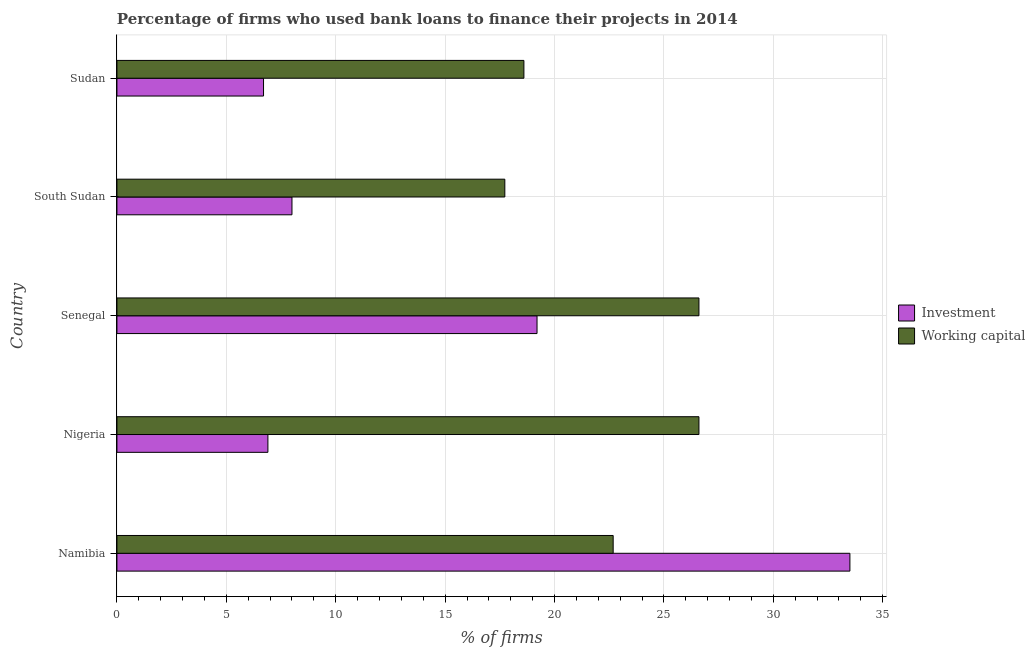Are the number of bars per tick equal to the number of legend labels?
Offer a terse response. Yes. Are the number of bars on each tick of the Y-axis equal?
Ensure brevity in your answer.  Yes. How many bars are there on the 5th tick from the top?
Ensure brevity in your answer.  2. How many bars are there on the 4th tick from the bottom?
Offer a very short reply. 2. What is the label of the 2nd group of bars from the top?
Keep it short and to the point. South Sudan. What is the percentage of firms using banks to finance investment in Sudan?
Offer a very short reply. 6.7. Across all countries, what is the maximum percentage of firms using banks to finance working capital?
Keep it short and to the point. 26.6. Across all countries, what is the minimum percentage of firms using banks to finance investment?
Ensure brevity in your answer.  6.7. In which country was the percentage of firms using banks to finance working capital maximum?
Your answer should be compact. Nigeria. In which country was the percentage of firms using banks to finance working capital minimum?
Your answer should be compact. South Sudan. What is the total percentage of firms using banks to finance working capital in the graph?
Offer a terse response. 112.21. What is the difference between the percentage of firms using banks to finance working capital in Namibia and that in Senegal?
Your answer should be compact. -3.92. What is the difference between the percentage of firms using banks to finance working capital in Sudan and the percentage of firms using banks to finance investment in Senegal?
Ensure brevity in your answer.  -0.6. What is the average percentage of firms using banks to finance investment per country?
Offer a very short reply. 14.86. What is the difference between the percentage of firms using banks to finance investment and percentage of firms using banks to finance working capital in Senegal?
Provide a succinct answer. -7.4. In how many countries, is the percentage of firms using banks to finance investment greater than 24 %?
Offer a terse response. 1. What is the ratio of the percentage of firms using banks to finance investment in Namibia to that in South Sudan?
Your answer should be compact. 4.19. What is the difference between the highest and the lowest percentage of firms using banks to finance working capital?
Give a very brief answer. 8.87. In how many countries, is the percentage of firms using banks to finance working capital greater than the average percentage of firms using banks to finance working capital taken over all countries?
Offer a very short reply. 3. Is the sum of the percentage of firms using banks to finance working capital in Senegal and South Sudan greater than the maximum percentage of firms using banks to finance investment across all countries?
Your answer should be very brief. Yes. What does the 1st bar from the top in Senegal represents?
Make the answer very short. Working capital. What does the 2nd bar from the bottom in Sudan represents?
Give a very brief answer. Working capital. Are all the bars in the graph horizontal?
Offer a terse response. Yes. How many countries are there in the graph?
Your answer should be very brief. 5. What is the difference between two consecutive major ticks on the X-axis?
Ensure brevity in your answer.  5. Are the values on the major ticks of X-axis written in scientific E-notation?
Your answer should be compact. No. Does the graph contain any zero values?
Your response must be concise. No. Does the graph contain grids?
Ensure brevity in your answer.  Yes. How many legend labels are there?
Offer a very short reply. 2. How are the legend labels stacked?
Offer a terse response. Vertical. What is the title of the graph?
Ensure brevity in your answer.  Percentage of firms who used bank loans to finance their projects in 2014. Does "Working only" appear as one of the legend labels in the graph?
Offer a terse response. No. What is the label or title of the X-axis?
Your response must be concise. % of firms. What is the label or title of the Y-axis?
Your answer should be compact. Country. What is the % of firms in Investment in Namibia?
Your response must be concise. 33.5. What is the % of firms in Working capital in Namibia?
Give a very brief answer. 22.68. What is the % of firms in Working capital in Nigeria?
Offer a terse response. 26.6. What is the % of firms of Investment in Senegal?
Your answer should be compact. 19.2. What is the % of firms of Working capital in Senegal?
Your response must be concise. 26.6. What is the % of firms in Working capital in South Sudan?
Offer a terse response. 17.73. Across all countries, what is the maximum % of firms of Investment?
Make the answer very short. 33.5. Across all countries, what is the maximum % of firms of Working capital?
Ensure brevity in your answer.  26.6. Across all countries, what is the minimum % of firms in Working capital?
Provide a succinct answer. 17.73. What is the total % of firms in Investment in the graph?
Offer a very short reply. 74.3. What is the total % of firms of Working capital in the graph?
Your answer should be compact. 112.21. What is the difference between the % of firms in Investment in Namibia and that in Nigeria?
Keep it short and to the point. 26.6. What is the difference between the % of firms of Working capital in Namibia and that in Nigeria?
Offer a very short reply. -3.92. What is the difference between the % of firms of Investment in Namibia and that in Senegal?
Give a very brief answer. 14.3. What is the difference between the % of firms in Working capital in Namibia and that in Senegal?
Your response must be concise. -3.92. What is the difference between the % of firms of Investment in Namibia and that in South Sudan?
Your answer should be very brief. 25.5. What is the difference between the % of firms of Working capital in Namibia and that in South Sudan?
Make the answer very short. 4.95. What is the difference between the % of firms in Investment in Namibia and that in Sudan?
Ensure brevity in your answer.  26.8. What is the difference between the % of firms in Working capital in Namibia and that in Sudan?
Offer a terse response. 4.08. What is the difference between the % of firms in Investment in Nigeria and that in Senegal?
Provide a succinct answer. -12.3. What is the difference between the % of firms of Working capital in Nigeria and that in South Sudan?
Your answer should be very brief. 8.87. What is the difference between the % of firms in Investment in Nigeria and that in Sudan?
Make the answer very short. 0.2. What is the difference between the % of firms in Working capital in Nigeria and that in Sudan?
Your answer should be very brief. 8. What is the difference between the % of firms in Investment in Senegal and that in South Sudan?
Your answer should be compact. 11.2. What is the difference between the % of firms of Working capital in Senegal and that in South Sudan?
Keep it short and to the point. 8.87. What is the difference between the % of firms of Investment in Senegal and that in Sudan?
Ensure brevity in your answer.  12.5. What is the difference between the % of firms of Working capital in South Sudan and that in Sudan?
Offer a terse response. -0.87. What is the difference between the % of firms in Investment in Namibia and the % of firms in Working capital in Nigeria?
Make the answer very short. 6.9. What is the difference between the % of firms in Investment in Namibia and the % of firms in Working capital in Senegal?
Keep it short and to the point. 6.9. What is the difference between the % of firms of Investment in Namibia and the % of firms of Working capital in South Sudan?
Your answer should be very brief. 15.77. What is the difference between the % of firms in Investment in Namibia and the % of firms in Working capital in Sudan?
Your answer should be very brief. 14.9. What is the difference between the % of firms in Investment in Nigeria and the % of firms in Working capital in Senegal?
Offer a terse response. -19.7. What is the difference between the % of firms in Investment in Nigeria and the % of firms in Working capital in South Sudan?
Provide a short and direct response. -10.83. What is the difference between the % of firms in Investment in Senegal and the % of firms in Working capital in South Sudan?
Provide a succinct answer. 1.47. What is the average % of firms of Investment per country?
Provide a succinct answer. 14.86. What is the average % of firms of Working capital per country?
Make the answer very short. 22.44. What is the difference between the % of firms in Investment and % of firms in Working capital in Namibia?
Your answer should be very brief. 10.82. What is the difference between the % of firms of Investment and % of firms of Working capital in Nigeria?
Make the answer very short. -19.7. What is the difference between the % of firms of Investment and % of firms of Working capital in Senegal?
Your answer should be very brief. -7.4. What is the difference between the % of firms in Investment and % of firms in Working capital in South Sudan?
Make the answer very short. -9.73. What is the difference between the % of firms of Investment and % of firms of Working capital in Sudan?
Your answer should be compact. -11.9. What is the ratio of the % of firms of Investment in Namibia to that in Nigeria?
Keep it short and to the point. 4.86. What is the ratio of the % of firms of Working capital in Namibia to that in Nigeria?
Make the answer very short. 0.85. What is the ratio of the % of firms of Investment in Namibia to that in Senegal?
Offer a very short reply. 1.74. What is the ratio of the % of firms of Working capital in Namibia to that in Senegal?
Your answer should be very brief. 0.85. What is the ratio of the % of firms of Investment in Namibia to that in South Sudan?
Provide a succinct answer. 4.19. What is the ratio of the % of firms in Working capital in Namibia to that in South Sudan?
Offer a terse response. 1.28. What is the ratio of the % of firms in Working capital in Namibia to that in Sudan?
Provide a short and direct response. 1.22. What is the ratio of the % of firms in Investment in Nigeria to that in Senegal?
Give a very brief answer. 0.36. What is the ratio of the % of firms in Investment in Nigeria to that in South Sudan?
Your response must be concise. 0.86. What is the ratio of the % of firms of Working capital in Nigeria to that in South Sudan?
Ensure brevity in your answer.  1.5. What is the ratio of the % of firms of Investment in Nigeria to that in Sudan?
Your answer should be very brief. 1.03. What is the ratio of the % of firms in Working capital in Nigeria to that in Sudan?
Provide a succinct answer. 1.43. What is the ratio of the % of firms in Working capital in Senegal to that in South Sudan?
Offer a very short reply. 1.5. What is the ratio of the % of firms of Investment in Senegal to that in Sudan?
Provide a succinct answer. 2.87. What is the ratio of the % of firms of Working capital in Senegal to that in Sudan?
Provide a succinct answer. 1.43. What is the ratio of the % of firms in Investment in South Sudan to that in Sudan?
Offer a very short reply. 1.19. What is the ratio of the % of firms in Working capital in South Sudan to that in Sudan?
Keep it short and to the point. 0.95. What is the difference between the highest and the lowest % of firms of Investment?
Make the answer very short. 26.8. What is the difference between the highest and the lowest % of firms of Working capital?
Give a very brief answer. 8.87. 